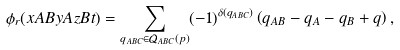Convert formula to latex. <formula><loc_0><loc_0><loc_500><loc_500>\phi _ { r } ( x A B y A z B t ) = \sum _ { q _ { A B C } \in \mathcal { Q } _ { A B C } ( p ) } ( - 1 ) ^ { \delta ( q _ { A B C } ) } \left ( q _ { A B } - q _ { A } - q _ { B } + q \right ) ,</formula> 